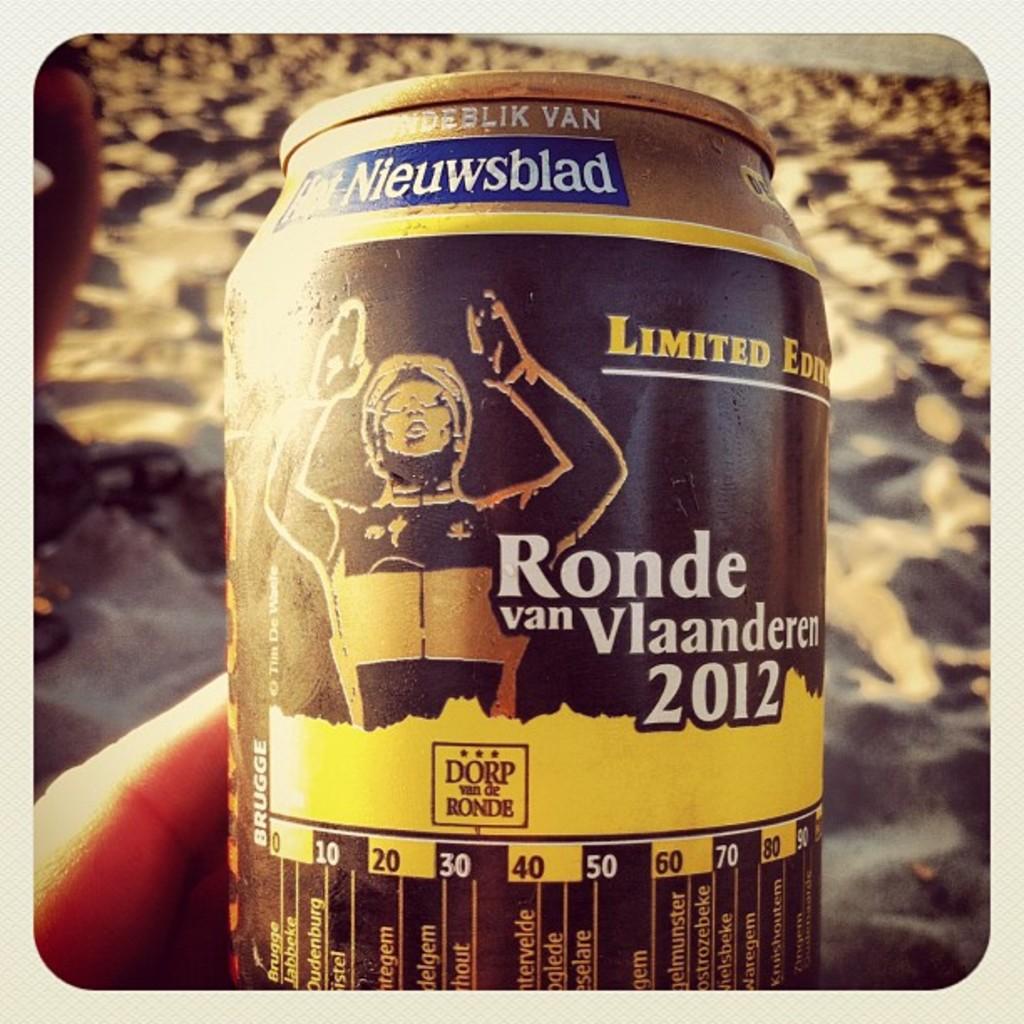What year is featured on this can?
Provide a short and direct response. 2012. What brand is it?
Keep it short and to the point. Nieuwsblad. 